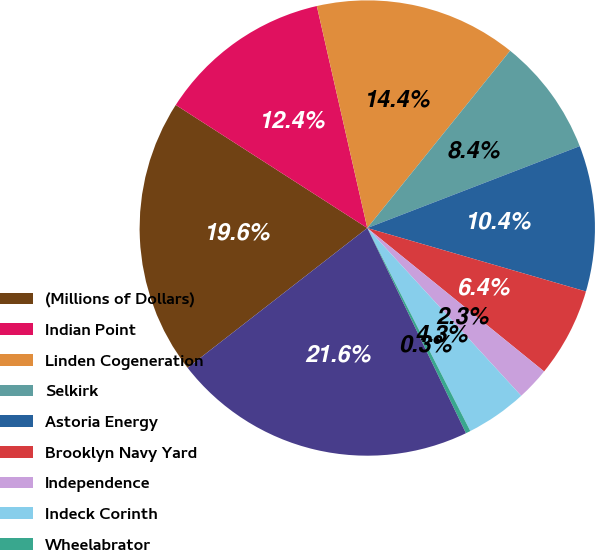Convert chart. <chart><loc_0><loc_0><loc_500><loc_500><pie_chart><fcel>(Millions of Dollars)<fcel>Indian Point<fcel>Linden Cogeneration<fcel>Selkirk<fcel>Astoria Energy<fcel>Brooklyn Navy Yard<fcel>Independence<fcel>Indeck Corinth<fcel>Wheelabrator<fcel>Total<nl><fcel>19.61%<fcel>12.35%<fcel>14.35%<fcel>8.35%<fcel>10.35%<fcel>6.35%<fcel>2.34%<fcel>4.34%<fcel>0.34%<fcel>21.61%<nl></chart> 